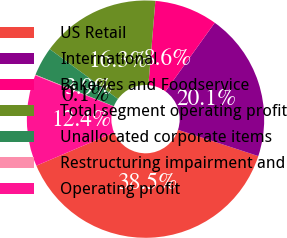Convert chart. <chart><loc_0><loc_0><loc_500><loc_500><pie_chart><fcel>US Retail<fcel>International<fcel>Bakeries and Foodservice<fcel>Total segment operating profit<fcel>Unallocated corporate items<fcel>Restructuring impairment and<fcel>Operating profit<nl><fcel>38.55%<fcel>20.13%<fcel>8.59%<fcel>16.28%<fcel>3.94%<fcel>0.09%<fcel>12.43%<nl></chart> 